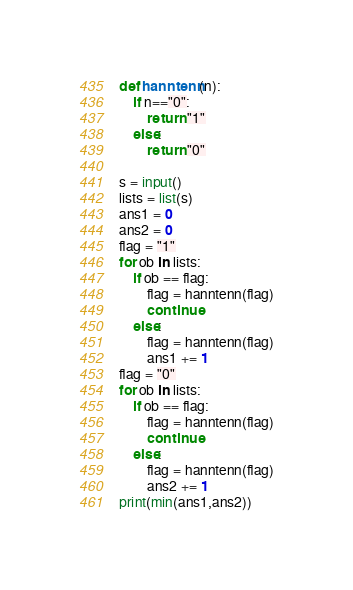Convert code to text. <code><loc_0><loc_0><loc_500><loc_500><_Python_>def hanntenn(n):
    if n=="0":
        return "1"
    else:
        return "0"
    
s = input()
lists = list(s)
ans1 = 0
ans2 = 0
flag = "1"
for ob in lists:
    if ob == flag:
        flag = hanntenn(flag)
        continue
    else:
        flag = hanntenn(flag)
        ans1 += 1
flag = "0"
for ob in lists:
    if ob == flag:
        flag = hanntenn(flag)
        continue
    else:
        flag = hanntenn(flag)
        ans2 += 1
print(min(ans1,ans2))</code> 